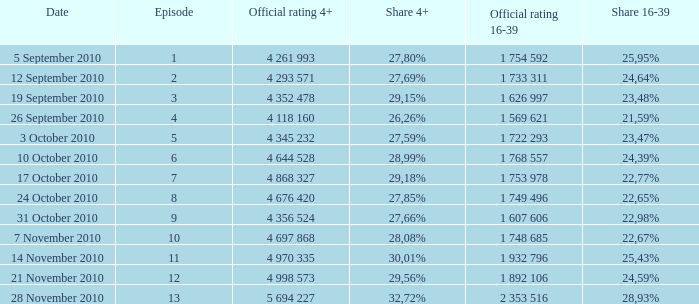What is the official 4+ rating of the episode with a 16-39 share of 24,59%? 4 998 573. 